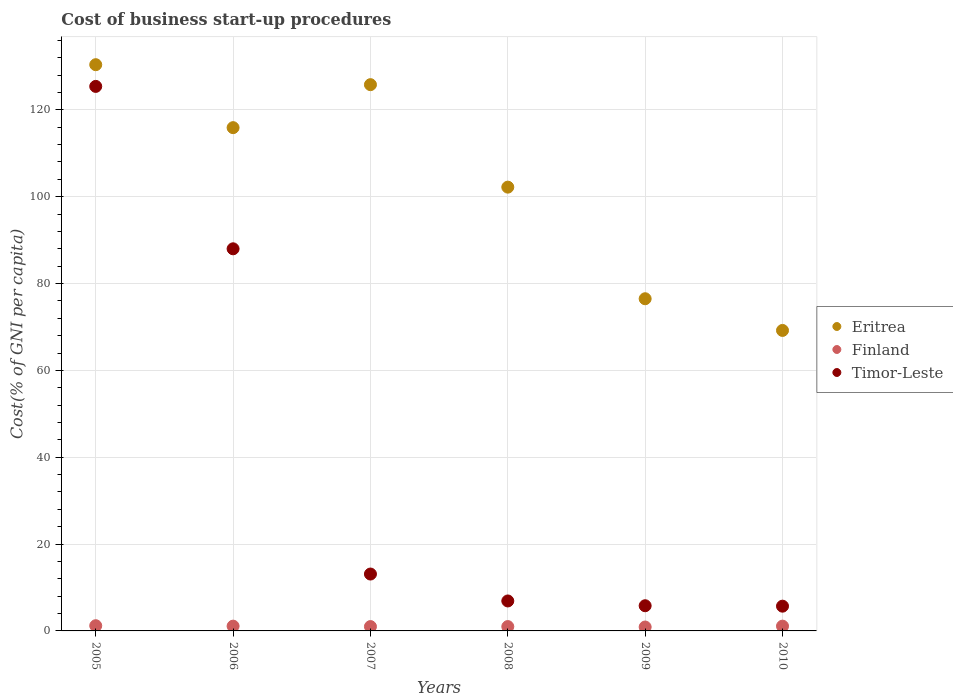Is the number of dotlines equal to the number of legend labels?
Provide a short and direct response. Yes. What is the cost of business start-up procedures in Eritrea in 2005?
Keep it short and to the point. 130.4. Across all years, what is the maximum cost of business start-up procedures in Eritrea?
Make the answer very short. 130.4. In which year was the cost of business start-up procedures in Finland maximum?
Your answer should be very brief. 2005. In which year was the cost of business start-up procedures in Timor-Leste minimum?
Offer a terse response. 2010. What is the total cost of business start-up procedures in Eritrea in the graph?
Offer a terse response. 620. What is the difference between the cost of business start-up procedures in Finland in 2006 and that in 2008?
Your answer should be very brief. 0.1. What is the difference between the cost of business start-up procedures in Timor-Leste in 2009 and the cost of business start-up procedures in Finland in 2010?
Provide a succinct answer. 4.7. What is the average cost of business start-up procedures in Timor-Leste per year?
Your answer should be compact. 40.82. In the year 2006, what is the difference between the cost of business start-up procedures in Finland and cost of business start-up procedures in Timor-Leste?
Provide a short and direct response. -86.9. What is the ratio of the cost of business start-up procedures in Eritrea in 2006 to that in 2007?
Ensure brevity in your answer.  0.92. Is the cost of business start-up procedures in Finland in 2008 less than that in 2010?
Offer a very short reply. Yes. What is the difference between the highest and the second highest cost of business start-up procedures in Eritrea?
Make the answer very short. 4.6. What is the difference between the highest and the lowest cost of business start-up procedures in Eritrea?
Offer a terse response. 61.2. Is it the case that in every year, the sum of the cost of business start-up procedures in Timor-Leste and cost of business start-up procedures in Finland  is greater than the cost of business start-up procedures in Eritrea?
Ensure brevity in your answer.  No. How many dotlines are there?
Offer a terse response. 3. How many years are there in the graph?
Your answer should be compact. 6. What is the difference between two consecutive major ticks on the Y-axis?
Your answer should be compact. 20. Are the values on the major ticks of Y-axis written in scientific E-notation?
Make the answer very short. No. Does the graph contain grids?
Provide a succinct answer. Yes. How many legend labels are there?
Give a very brief answer. 3. How are the legend labels stacked?
Your answer should be very brief. Vertical. What is the title of the graph?
Provide a succinct answer. Cost of business start-up procedures. What is the label or title of the Y-axis?
Offer a terse response. Cost(% of GNI per capita). What is the Cost(% of GNI per capita) in Eritrea in 2005?
Provide a succinct answer. 130.4. What is the Cost(% of GNI per capita) of Timor-Leste in 2005?
Keep it short and to the point. 125.4. What is the Cost(% of GNI per capita) of Eritrea in 2006?
Provide a succinct answer. 115.9. What is the Cost(% of GNI per capita) of Eritrea in 2007?
Your answer should be compact. 125.8. What is the Cost(% of GNI per capita) in Eritrea in 2008?
Provide a succinct answer. 102.2. What is the Cost(% of GNI per capita) of Finland in 2008?
Provide a short and direct response. 1. What is the Cost(% of GNI per capita) of Eritrea in 2009?
Your response must be concise. 76.5. What is the Cost(% of GNI per capita) of Timor-Leste in 2009?
Make the answer very short. 5.8. What is the Cost(% of GNI per capita) of Eritrea in 2010?
Your answer should be compact. 69.2. What is the Cost(% of GNI per capita) in Timor-Leste in 2010?
Ensure brevity in your answer.  5.7. Across all years, what is the maximum Cost(% of GNI per capita) in Eritrea?
Your response must be concise. 130.4. Across all years, what is the maximum Cost(% of GNI per capita) of Finland?
Make the answer very short. 1.2. Across all years, what is the maximum Cost(% of GNI per capita) of Timor-Leste?
Offer a terse response. 125.4. Across all years, what is the minimum Cost(% of GNI per capita) in Eritrea?
Keep it short and to the point. 69.2. Across all years, what is the minimum Cost(% of GNI per capita) in Finland?
Offer a very short reply. 0.9. Across all years, what is the minimum Cost(% of GNI per capita) in Timor-Leste?
Provide a short and direct response. 5.7. What is the total Cost(% of GNI per capita) in Eritrea in the graph?
Offer a terse response. 620. What is the total Cost(% of GNI per capita) of Timor-Leste in the graph?
Offer a very short reply. 244.9. What is the difference between the Cost(% of GNI per capita) of Timor-Leste in 2005 and that in 2006?
Offer a terse response. 37.4. What is the difference between the Cost(% of GNI per capita) in Timor-Leste in 2005 and that in 2007?
Your answer should be very brief. 112.3. What is the difference between the Cost(% of GNI per capita) of Eritrea in 2005 and that in 2008?
Make the answer very short. 28.2. What is the difference between the Cost(% of GNI per capita) in Timor-Leste in 2005 and that in 2008?
Ensure brevity in your answer.  118.5. What is the difference between the Cost(% of GNI per capita) in Eritrea in 2005 and that in 2009?
Your answer should be very brief. 53.9. What is the difference between the Cost(% of GNI per capita) of Finland in 2005 and that in 2009?
Keep it short and to the point. 0.3. What is the difference between the Cost(% of GNI per capita) in Timor-Leste in 2005 and that in 2009?
Your answer should be compact. 119.6. What is the difference between the Cost(% of GNI per capita) of Eritrea in 2005 and that in 2010?
Offer a very short reply. 61.2. What is the difference between the Cost(% of GNI per capita) of Finland in 2005 and that in 2010?
Keep it short and to the point. 0.1. What is the difference between the Cost(% of GNI per capita) of Timor-Leste in 2005 and that in 2010?
Offer a terse response. 119.7. What is the difference between the Cost(% of GNI per capita) of Eritrea in 2006 and that in 2007?
Ensure brevity in your answer.  -9.9. What is the difference between the Cost(% of GNI per capita) of Timor-Leste in 2006 and that in 2007?
Provide a short and direct response. 74.9. What is the difference between the Cost(% of GNI per capita) of Finland in 2006 and that in 2008?
Give a very brief answer. 0.1. What is the difference between the Cost(% of GNI per capita) in Timor-Leste in 2006 and that in 2008?
Ensure brevity in your answer.  81.1. What is the difference between the Cost(% of GNI per capita) in Eritrea in 2006 and that in 2009?
Provide a succinct answer. 39.4. What is the difference between the Cost(% of GNI per capita) in Timor-Leste in 2006 and that in 2009?
Ensure brevity in your answer.  82.2. What is the difference between the Cost(% of GNI per capita) in Eritrea in 2006 and that in 2010?
Ensure brevity in your answer.  46.7. What is the difference between the Cost(% of GNI per capita) of Finland in 2006 and that in 2010?
Offer a very short reply. 0. What is the difference between the Cost(% of GNI per capita) of Timor-Leste in 2006 and that in 2010?
Make the answer very short. 82.3. What is the difference between the Cost(% of GNI per capita) in Eritrea in 2007 and that in 2008?
Your answer should be very brief. 23.6. What is the difference between the Cost(% of GNI per capita) of Finland in 2007 and that in 2008?
Make the answer very short. 0. What is the difference between the Cost(% of GNI per capita) of Eritrea in 2007 and that in 2009?
Give a very brief answer. 49.3. What is the difference between the Cost(% of GNI per capita) in Finland in 2007 and that in 2009?
Provide a short and direct response. 0.1. What is the difference between the Cost(% of GNI per capita) in Timor-Leste in 2007 and that in 2009?
Your answer should be compact. 7.3. What is the difference between the Cost(% of GNI per capita) of Eritrea in 2007 and that in 2010?
Give a very brief answer. 56.6. What is the difference between the Cost(% of GNI per capita) in Eritrea in 2008 and that in 2009?
Your answer should be compact. 25.7. What is the difference between the Cost(% of GNI per capita) in Eritrea in 2008 and that in 2010?
Provide a succinct answer. 33. What is the difference between the Cost(% of GNI per capita) of Finland in 2008 and that in 2010?
Offer a terse response. -0.1. What is the difference between the Cost(% of GNI per capita) in Timor-Leste in 2008 and that in 2010?
Offer a terse response. 1.2. What is the difference between the Cost(% of GNI per capita) in Eritrea in 2009 and that in 2010?
Give a very brief answer. 7.3. What is the difference between the Cost(% of GNI per capita) of Finland in 2009 and that in 2010?
Provide a succinct answer. -0.2. What is the difference between the Cost(% of GNI per capita) of Timor-Leste in 2009 and that in 2010?
Make the answer very short. 0.1. What is the difference between the Cost(% of GNI per capita) in Eritrea in 2005 and the Cost(% of GNI per capita) in Finland in 2006?
Give a very brief answer. 129.3. What is the difference between the Cost(% of GNI per capita) of Eritrea in 2005 and the Cost(% of GNI per capita) of Timor-Leste in 2006?
Provide a succinct answer. 42.4. What is the difference between the Cost(% of GNI per capita) in Finland in 2005 and the Cost(% of GNI per capita) in Timor-Leste in 2006?
Make the answer very short. -86.8. What is the difference between the Cost(% of GNI per capita) of Eritrea in 2005 and the Cost(% of GNI per capita) of Finland in 2007?
Provide a short and direct response. 129.4. What is the difference between the Cost(% of GNI per capita) of Eritrea in 2005 and the Cost(% of GNI per capita) of Timor-Leste in 2007?
Offer a terse response. 117.3. What is the difference between the Cost(% of GNI per capita) of Eritrea in 2005 and the Cost(% of GNI per capita) of Finland in 2008?
Your answer should be compact. 129.4. What is the difference between the Cost(% of GNI per capita) of Eritrea in 2005 and the Cost(% of GNI per capita) of Timor-Leste in 2008?
Make the answer very short. 123.5. What is the difference between the Cost(% of GNI per capita) of Finland in 2005 and the Cost(% of GNI per capita) of Timor-Leste in 2008?
Provide a succinct answer. -5.7. What is the difference between the Cost(% of GNI per capita) in Eritrea in 2005 and the Cost(% of GNI per capita) in Finland in 2009?
Provide a succinct answer. 129.5. What is the difference between the Cost(% of GNI per capita) of Eritrea in 2005 and the Cost(% of GNI per capita) of Timor-Leste in 2009?
Your answer should be compact. 124.6. What is the difference between the Cost(% of GNI per capita) in Eritrea in 2005 and the Cost(% of GNI per capita) in Finland in 2010?
Keep it short and to the point. 129.3. What is the difference between the Cost(% of GNI per capita) in Eritrea in 2005 and the Cost(% of GNI per capita) in Timor-Leste in 2010?
Keep it short and to the point. 124.7. What is the difference between the Cost(% of GNI per capita) of Finland in 2005 and the Cost(% of GNI per capita) of Timor-Leste in 2010?
Provide a short and direct response. -4.5. What is the difference between the Cost(% of GNI per capita) of Eritrea in 2006 and the Cost(% of GNI per capita) of Finland in 2007?
Offer a terse response. 114.9. What is the difference between the Cost(% of GNI per capita) of Eritrea in 2006 and the Cost(% of GNI per capita) of Timor-Leste in 2007?
Your answer should be compact. 102.8. What is the difference between the Cost(% of GNI per capita) in Eritrea in 2006 and the Cost(% of GNI per capita) in Finland in 2008?
Your answer should be very brief. 114.9. What is the difference between the Cost(% of GNI per capita) of Eritrea in 2006 and the Cost(% of GNI per capita) of Timor-Leste in 2008?
Provide a succinct answer. 109. What is the difference between the Cost(% of GNI per capita) in Finland in 2006 and the Cost(% of GNI per capita) in Timor-Leste in 2008?
Your answer should be very brief. -5.8. What is the difference between the Cost(% of GNI per capita) of Eritrea in 2006 and the Cost(% of GNI per capita) of Finland in 2009?
Ensure brevity in your answer.  115. What is the difference between the Cost(% of GNI per capita) of Eritrea in 2006 and the Cost(% of GNI per capita) of Timor-Leste in 2009?
Offer a terse response. 110.1. What is the difference between the Cost(% of GNI per capita) of Eritrea in 2006 and the Cost(% of GNI per capita) of Finland in 2010?
Offer a very short reply. 114.8. What is the difference between the Cost(% of GNI per capita) of Eritrea in 2006 and the Cost(% of GNI per capita) of Timor-Leste in 2010?
Provide a short and direct response. 110.2. What is the difference between the Cost(% of GNI per capita) of Eritrea in 2007 and the Cost(% of GNI per capita) of Finland in 2008?
Ensure brevity in your answer.  124.8. What is the difference between the Cost(% of GNI per capita) of Eritrea in 2007 and the Cost(% of GNI per capita) of Timor-Leste in 2008?
Your answer should be very brief. 118.9. What is the difference between the Cost(% of GNI per capita) of Eritrea in 2007 and the Cost(% of GNI per capita) of Finland in 2009?
Make the answer very short. 124.9. What is the difference between the Cost(% of GNI per capita) in Eritrea in 2007 and the Cost(% of GNI per capita) in Timor-Leste in 2009?
Keep it short and to the point. 120. What is the difference between the Cost(% of GNI per capita) of Eritrea in 2007 and the Cost(% of GNI per capita) of Finland in 2010?
Give a very brief answer. 124.7. What is the difference between the Cost(% of GNI per capita) of Eritrea in 2007 and the Cost(% of GNI per capita) of Timor-Leste in 2010?
Make the answer very short. 120.1. What is the difference between the Cost(% of GNI per capita) in Finland in 2007 and the Cost(% of GNI per capita) in Timor-Leste in 2010?
Offer a very short reply. -4.7. What is the difference between the Cost(% of GNI per capita) of Eritrea in 2008 and the Cost(% of GNI per capita) of Finland in 2009?
Give a very brief answer. 101.3. What is the difference between the Cost(% of GNI per capita) of Eritrea in 2008 and the Cost(% of GNI per capita) of Timor-Leste in 2009?
Your answer should be compact. 96.4. What is the difference between the Cost(% of GNI per capita) in Eritrea in 2008 and the Cost(% of GNI per capita) in Finland in 2010?
Ensure brevity in your answer.  101.1. What is the difference between the Cost(% of GNI per capita) in Eritrea in 2008 and the Cost(% of GNI per capita) in Timor-Leste in 2010?
Your answer should be compact. 96.5. What is the difference between the Cost(% of GNI per capita) in Eritrea in 2009 and the Cost(% of GNI per capita) in Finland in 2010?
Your response must be concise. 75.4. What is the difference between the Cost(% of GNI per capita) of Eritrea in 2009 and the Cost(% of GNI per capita) of Timor-Leste in 2010?
Your response must be concise. 70.8. What is the difference between the Cost(% of GNI per capita) of Finland in 2009 and the Cost(% of GNI per capita) of Timor-Leste in 2010?
Provide a succinct answer. -4.8. What is the average Cost(% of GNI per capita) of Eritrea per year?
Offer a terse response. 103.33. What is the average Cost(% of GNI per capita) in Finland per year?
Offer a terse response. 1.05. What is the average Cost(% of GNI per capita) of Timor-Leste per year?
Ensure brevity in your answer.  40.82. In the year 2005, what is the difference between the Cost(% of GNI per capita) in Eritrea and Cost(% of GNI per capita) in Finland?
Provide a short and direct response. 129.2. In the year 2005, what is the difference between the Cost(% of GNI per capita) in Eritrea and Cost(% of GNI per capita) in Timor-Leste?
Keep it short and to the point. 5. In the year 2005, what is the difference between the Cost(% of GNI per capita) of Finland and Cost(% of GNI per capita) of Timor-Leste?
Your response must be concise. -124.2. In the year 2006, what is the difference between the Cost(% of GNI per capita) in Eritrea and Cost(% of GNI per capita) in Finland?
Your response must be concise. 114.8. In the year 2006, what is the difference between the Cost(% of GNI per capita) in Eritrea and Cost(% of GNI per capita) in Timor-Leste?
Make the answer very short. 27.9. In the year 2006, what is the difference between the Cost(% of GNI per capita) of Finland and Cost(% of GNI per capita) of Timor-Leste?
Make the answer very short. -86.9. In the year 2007, what is the difference between the Cost(% of GNI per capita) in Eritrea and Cost(% of GNI per capita) in Finland?
Provide a succinct answer. 124.8. In the year 2007, what is the difference between the Cost(% of GNI per capita) in Eritrea and Cost(% of GNI per capita) in Timor-Leste?
Offer a very short reply. 112.7. In the year 2007, what is the difference between the Cost(% of GNI per capita) of Finland and Cost(% of GNI per capita) of Timor-Leste?
Make the answer very short. -12.1. In the year 2008, what is the difference between the Cost(% of GNI per capita) in Eritrea and Cost(% of GNI per capita) in Finland?
Ensure brevity in your answer.  101.2. In the year 2008, what is the difference between the Cost(% of GNI per capita) in Eritrea and Cost(% of GNI per capita) in Timor-Leste?
Your answer should be compact. 95.3. In the year 2009, what is the difference between the Cost(% of GNI per capita) of Eritrea and Cost(% of GNI per capita) of Finland?
Provide a succinct answer. 75.6. In the year 2009, what is the difference between the Cost(% of GNI per capita) of Eritrea and Cost(% of GNI per capita) of Timor-Leste?
Your response must be concise. 70.7. In the year 2009, what is the difference between the Cost(% of GNI per capita) of Finland and Cost(% of GNI per capita) of Timor-Leste?
Give a very brief answer. -4.9. In the year 2010, what is the difference between the Cost(% of GNI per capita) of Eritrea and Cost(% of GNI per capita) of Finland?
Your response must be concise. 68.1. In the year 2010, what is the difference between the Cost(% of GNI per capita) in Eritrea and Cost(% of GNI per capita) in Timor-Leste?
Offer a terse response. 63.5. What is the ratio of the Cost(% of GNI per capita) in Eritrea in 2005 to that in 2006?
Keep it short and to the point. 1.13. What is the ratio of the Cost(% of GNI per capita) in Finland in 2005 to that in 2006?
Ensure brevity in your answer.  1.09. What is the ratio of the Cost(% of GNI per capita) of Timor-Leste in 2005 to that in 2006?
Your answer should be compact. 1.43. What is the ratio of the Cost(% of GNI per capita) in Eritrea in 2005 to that in 2007?
Your response must be concise. 1.04. What is the ratio of the Cost(% of GNI per capita) in Timor-Leste in 2005 to that in 2007?
Give a very brief answer. 9.57. What is the ratio of the Cost(% of GNI per capita) of Eritrea in 2005 to that in 2008?
Make the answer very short. 1.28. What is the ratio of the Cost(% of GNI per capita) in Finland in 2005 to that in 2008?
Give a very brief answer. 1.2. What is the ratio of the Cost(% of GNI per capita) in Timor-Leste in 2005 to that in 2008?
Give a very brief answer. 18.17. What is the ratio of the Cost(% of GNI per capita) in Eritrea in 2005 to that in 2009?
Keep it short and to the point. 1.7. What is the ratio of the Cost(% of GNI per capita) of Timor-Leste in 2005 to that in 2009?
Provide a short and direct response. 21.62. What is the ratio of the Cost(% of GNI per capita) of Eritrea in 2005 to that in 2010?
Offer a terse response. 1.88. What is the ratio of the Cost(% of GNI per capita) in Timor-Leste in 2005 to that in 2010?
Your answer should be very brief. 22. What is the ratio of the Cost(% of GNI per capita) in Eritrea in 2006 to that in 2007?
Your response must be concise. 0.92. What is the ratio of the Cost(% of GNI per capita) in Timor-Leste in 2006 to that in 2007?
Your answer should be very brief. 6.72. What is the ratio of the Cost(% of GNI per capita) in Eritrea in 2006 to that in 2008?
Your answer should be compact. 1.13. What is the ratio of the Cost(% of GNI per capita) in Finland in 2006 to that in 2008?
Provide a succinct answer. 1.1. What is the ratio of the Cost(% of GNI per capita) in Timor-Leste in 2006 to that in 2008?
Provide a short and direct response. 12.75. What is the ratio of the Cost(% of GNI per capita) in Eritrea in 2006 to that in 2009?
Your answer should be compact. 1.51. What is the ratio of the Cost(% of GNI per capita) of Finland in 2006 to that in 2009?
Your answer should be compact. 1.22. What is the ratio of the Cost(% of GNI per capita) of Timor-Leste in 2006 to that in 2009?
Ensure brevity in your answer.  15.17. What is the ratio of the Cost(% of GNI per capita) in Eritrea in 2006 to that in 2010?
Give a very brief answer. 1.67. What is the ratio of the Cost(% of GNI per capita) of Finland in 2006 to that in 2010?
Your response must be concise. 1. What is the ratio of the Cost(% of GNI per capita) in Timor-Leste in 2006 to that in 2010?
Provide a succinct answer. 15.44. What is the ratio of the Cost(% of GNI per capita) in Eritrea in 2007 to that in 2008?
Offer a very short reply. 1.23. What is the ratio of the Cost(% of GNI per capita) in Timor-Leste in 2007 to that in 2008?
Provide a succinct answer. 1.9. What is the ratio of the Cost(% of GNI per capita) of Eritrea in 2007 to that in 2009?
Give a very brief answer. 1.64. What is the ratio of the Cost(% of GNI per capita) of Timor-Leste in 2007 to that in 2009?
Offer a terse response. 2.26. What is the ratio of the Cost(% of GNI per capita) of Eritrea in 2007 to that in 2010?
Keep it short and to the point. 1.82. What is the ratio of the Cost(% of GNI per capita) in Finland in 2007 to that in 2010?
Offer a very short reply. 0.91. What is the ratio of the Cost(% of GNI per capita) in Timor-Leste in 2007 to that in 2010?
Your response must be concise. 2.3. What is the ratio of the Cost(% of GNI per capita) in Eritrea in 2008 to that in 2009?
Your response must be concise. 1.34. What is the ratio of the Cost(% of GNI per capita) of Finland in 2008 to that in 2009?
Offer a terse response. 1.11. What is the ratio of the Cost(% of GNI per capita) in Timor-Leste in 2008 to that in 2009?
Offer a terse response. 1.19. What is the ratio of the Cost(% of GNI per capita) in Eritrea in 2008 to that in 2010?
Provide a short and direct response. 1.48. What is the ratio of the Cost(% of GNI per capita) of Timor-Leste in 2008 to that in 2010?
Your response must be concise. 1.21. What is the ratio of the Cost(% of GNI per capita) of Eritrea in 2009 to that in 2010?
Provide a short and direct response. 1.11. What is the ratio of the Cost(% of GNI per capita) of Finland in 2009 to that in 2010?
Your answer should be compact. 0.82. What is the ratio of the Cost(% of GNI per capita) in Timor-Leste in 2009 to that in 2010?
Ensure brevity in your answer.  1.02. What is the difference between the highest and the second highest Cost(% of GNI per capita) in Timor-Leste?
Give a very brief answer. 37.4. What is the difference between the highest and the lowest Cost(% of GNI per capita) in Eritrea?
Make the answer very short. 61.2. What is the difference between the highest and the lowest Cost(% of GNI per capita) of Finland?
Your answer should be very brief. 0.3. What is the difference between the highest and the lowest Cost(% of GNI per capita) of Timor-Leste?
Make the answer very short. 119.7. 